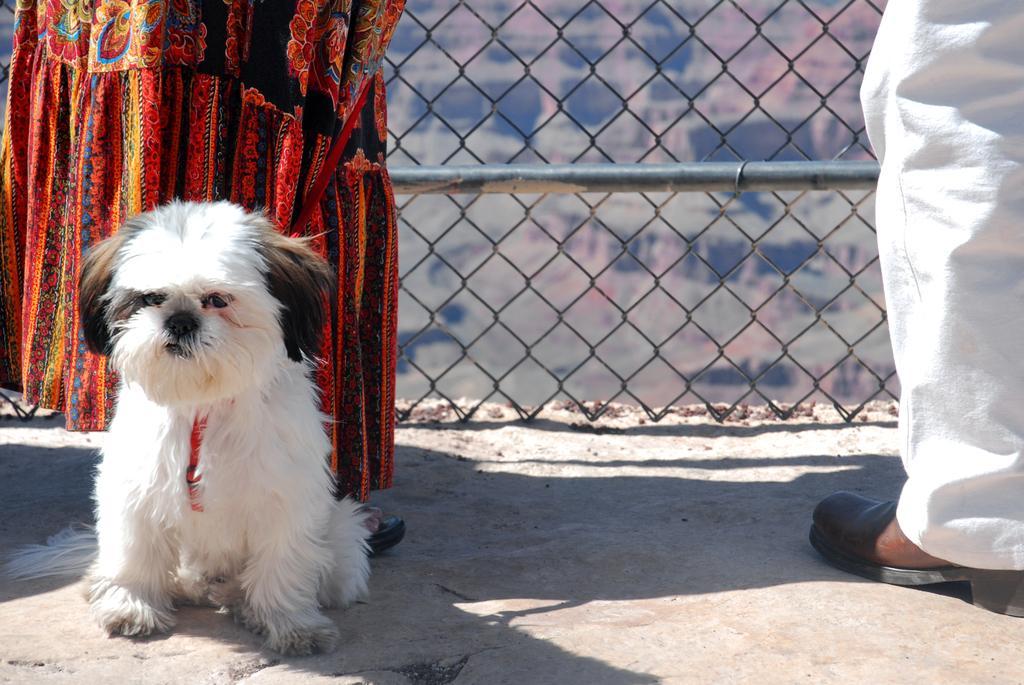Please provide a concise description of this image. In this image I can see two people and the dog. I can see the dog is in white, black and cream color. In the background I can see the metal rod and fence. 